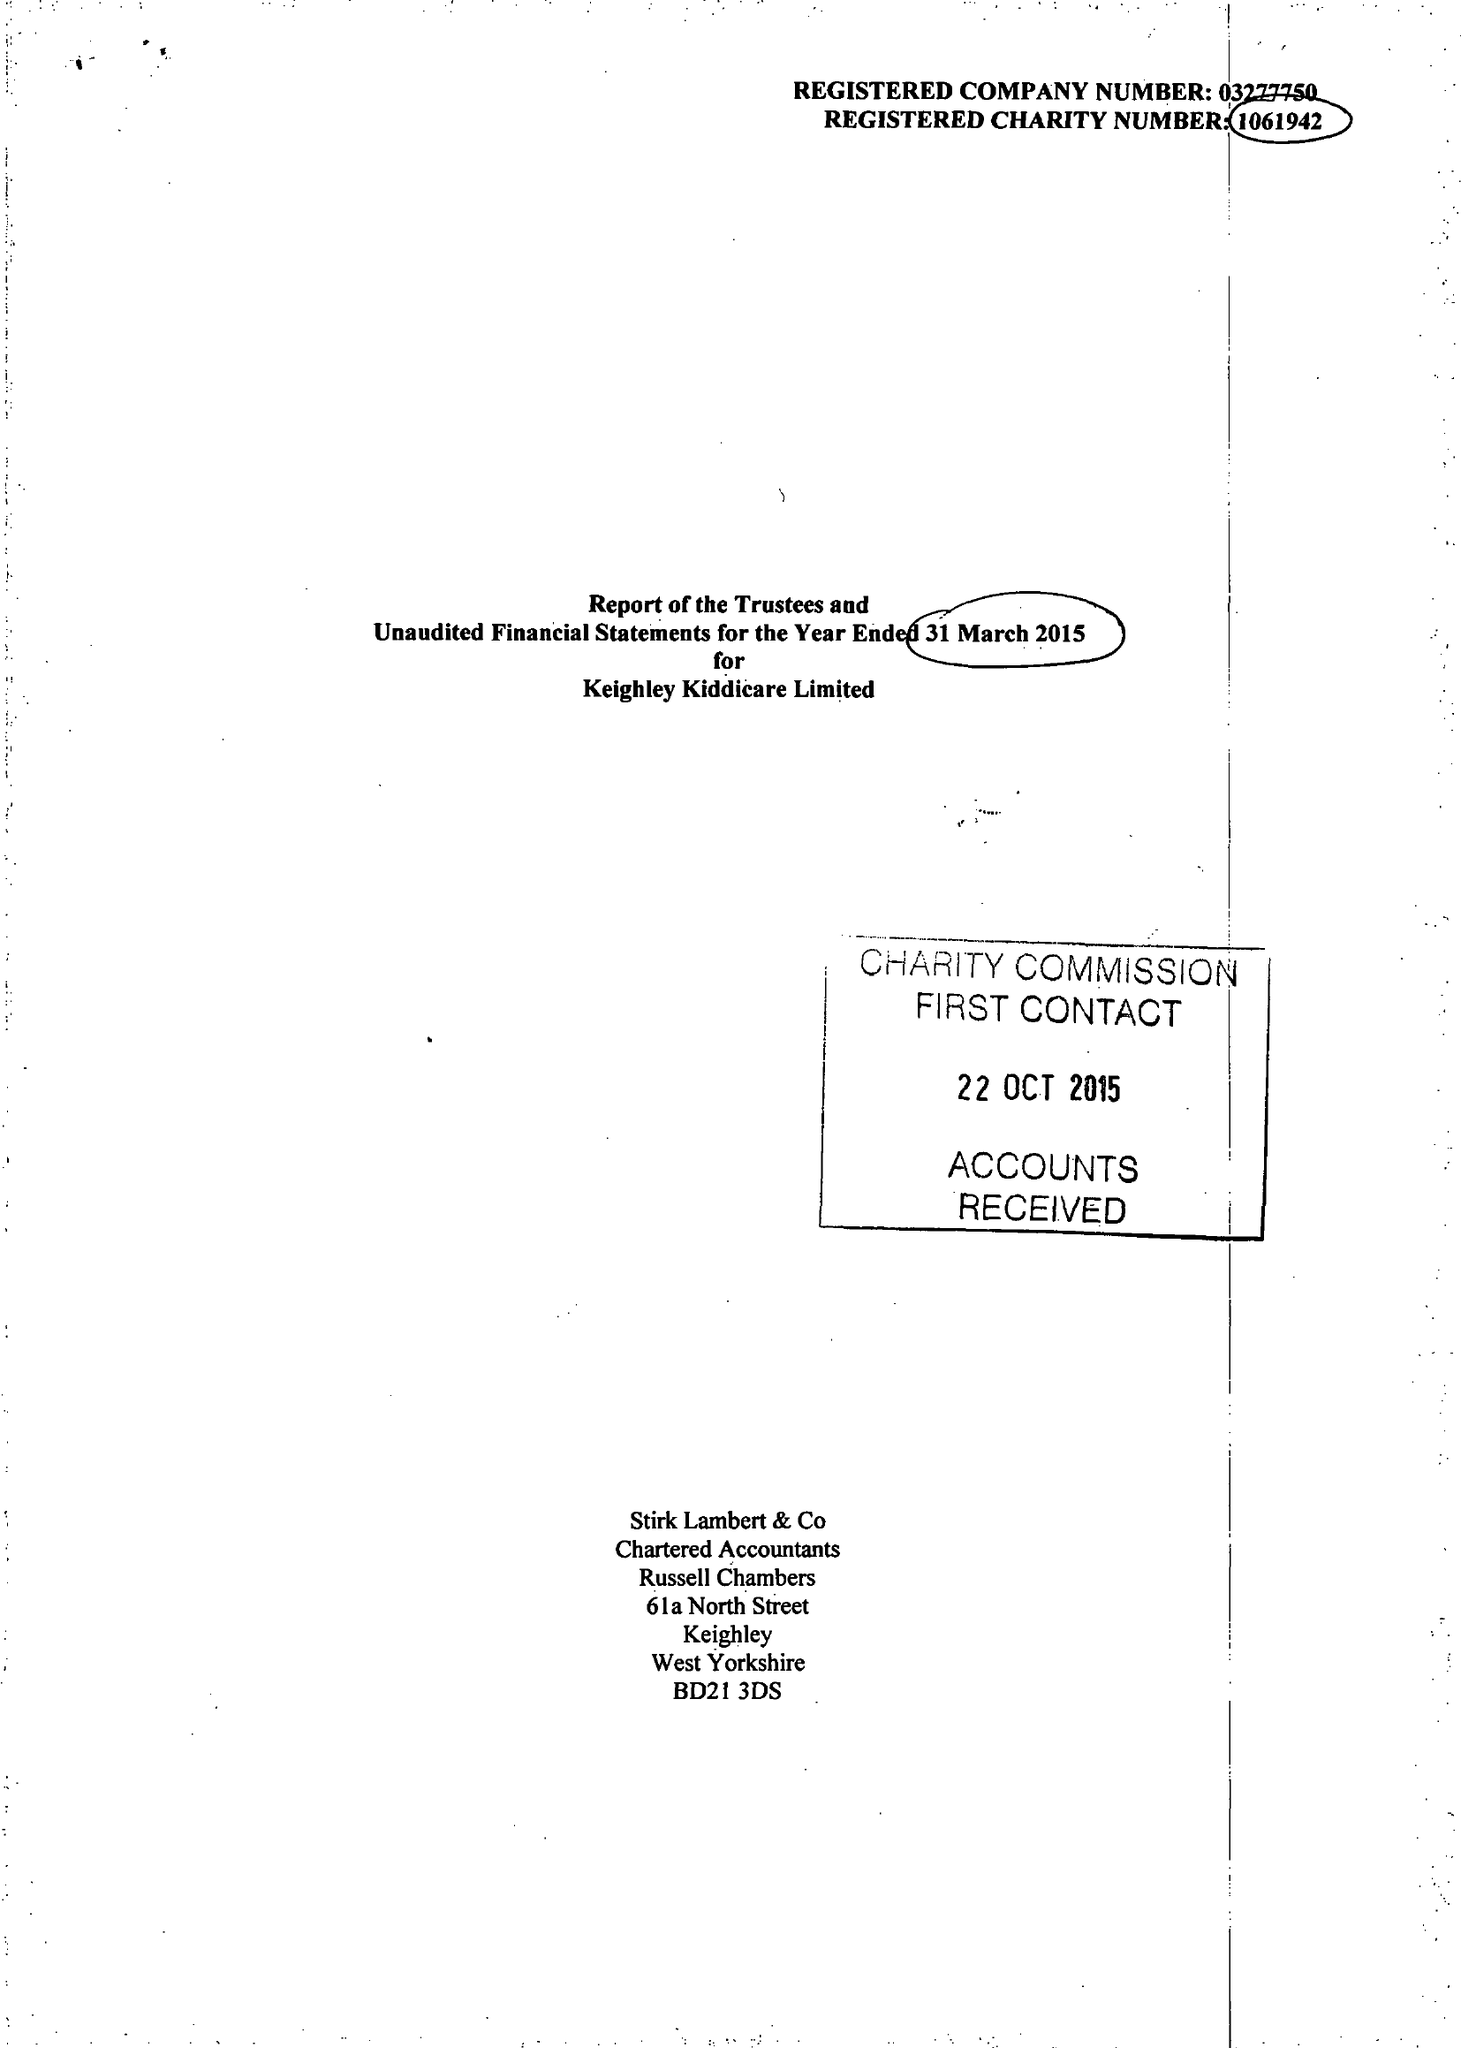What is the value for the charity_number?
Answer the question using a single word or phrase. 1061942 